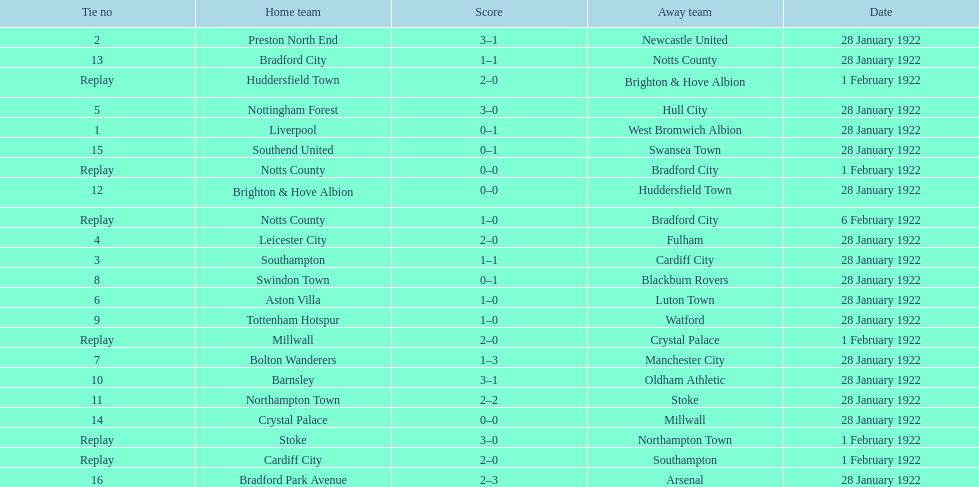Who is the first home team listed as having a score of 3-1? Preston North End. 